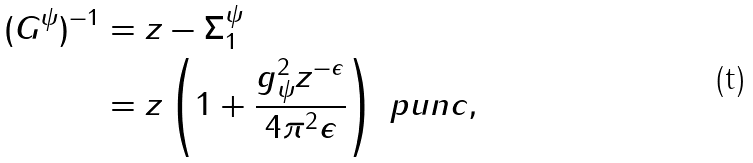Convert formula to latex. <formula><loc_0><loc_0><loc_500><loc_500>( G ^ { \psi } ) ^ { - 1 } & = z - \Sigma ^ { \psi } _ { 1 } \\ & = z \left ( 1 + \frac { g _ { \psi } ^ { 2 } z ^ { - \epsilon } } { 4 \pi ^ { 2 } \epsilon } \right ) \ p u n c { , }</formula> 